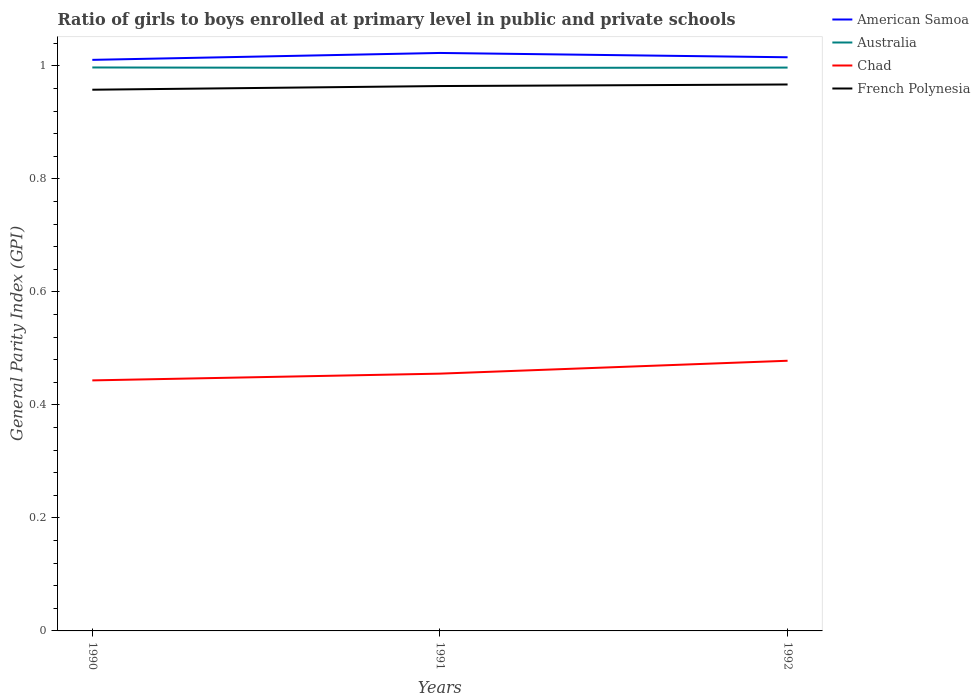How many different coloured lines are there?
Keep it short and to the point. 4. Is the number of lines equal to the number of legend labels?
Your answer should be very brief. Yes. Across all years, what is the maximum general parity index in Australia?
Your answer should be compact. 1. What is the total general parity index in Chad in the graph?
Make the answer very short. -0.03. What is the difference between the highest and the second highest general parity index in French Polynesia?
Give a very brief answer. 0.01. What is the difference between the highest and the lowest general parity index in Chad?
Provide a succinct answer. 1. Is the general parity index in Australia strictly greater than the general parity index in American Samoa over the years?
Your response must be concise. Yes. Does the graph contain any zero values?
Provide a short and direct response. No. Does the graph contain grids?
Give a very brief answer. No. Where does the legend appear in the graph?
Give a very brief answer. Top right. How many legend labels are there?
Keep it short and to the point. 4. What is the title of the graph?
Give a very brief answer. Ratio of girls to boys enrolled at primary level in public and private schools. What is the label or title of the X-axis?
Keep it short and to the point. Years. What is the label or title of the Y-axis?
Keep it short and to the point. General Parity Index (GPI). What is the General Parity Index (GPI) in American Samoa in 1990?
Give a very brief answer. 1.01. What is the General Parity Index (GPI) in Australia in 1990?
Ensure brevity in your answer.  1. What is the General Parity Index (GPI) in Chad in 1990?
Give a very brief answer. 0.44. What is the General Parity Index (GPI) in French Polynesia in 1990?
Your answer should be compact. 0.96. What is the General Parity Index (GPI) in American Samoa in 1991?
Provide a short and direct response. 1.02. What is the General Parity Index (GPI) of Australia in 1991?
Give a very brief answer. 1. What is the General Parity Index (GPI) of Chad in 1991?
Provide a succinct answer. 0.46. What is the General Parity Index (GPI) of French Polynesia in 1991?
Ensure brevity in your answer.  0.96. What is the General Parity Index (GPI) in American Samoa in 1992?
Your answer should be compact. 1.02. What is the General Parity Index (GPI) of Australia in 1992?
Give a very brief answer. 1. What is the General Parity Index (GPI) in Chad in 1992?
Make the answer very short. 0.48. What is the General Parity Index (GPI) of French Polynesia in 1992?
Make the answer very short. 0.97. Across all years, what is the maximum General Parity Index (GPI) in American Samoa?
Give a very brief answer. 1.02. Across all years, what is the maximum General Parity Index (GPI) of Australia?
Ensure brevity in your answer.  1. Across all years, what is the maximum General Parity Index (GPI) in Chad?
Your response must be concise. 0.48. Across all years, what is the maximum General Parity Index (GPI) of French Polynesia?
Make the answer very short. 0.97. Across all years, what is the minimum General Parity Index (GPI) in American Samoa?
Provide a succinct answer. 1.01. Across all years, what is the minimum General Parity Index (GPI) in Australia?
Give a very brief answer. 1. Across all years, what is the minimum General Parity Index (GPI) of Chad?
Make the answer very short. 0.44. Across all years, what is the minimum General Parity Index (GPI) in French Polynesia?
Provide a succinct answer. 0.96. What is the total General Parity Index (GPI) in American Samoa in the graph?
Your answer should be very brief. 3.05. What is the total General Parity Index (GPI) in Australia in the graph?
Make the answer very short. 2.99. What is the total General Parity Index (GPI) of Chad in the graph?
Your response must be concise. 1.38. What is the total General Parity Index (GPI) in French Polynesia in the graph?
Provide a short and direct response. 2.89. What is the difference between the General Parity Index (GPI) in American Samoa in 1990 and that in 1991?
Your answer should be very brief. -0.01. What is the difference between the General Parity Index (GPI) of Australia in 1990 and that in 1991?
Ensure brevity in your answer.  0. What is the difference between the General Parity Index (GPI) of Chad in 1990 and that in 1991?
Your response must be concise. -0.01. What is the difference between the General Parity Index (GPI) in French Polynesia in 1990 and that in 1991?
Offer a very short reply. -0.01. What is the difference between the General Parity Index (GPI) in American Samoa in 1990 and that in 1992?
Ensure brevity in your answer.  -0. What is the difference between the General Parity Index (GPI) in Australia in 1990 and that in 1992?
Your response must be concise. 0. What is the difference between the General Parity Index (GPI) in Chad in 1990 and that in 1992?
Give a very brief answer. -0.03. What is the difference between the General Parity Index (GPI) of French Polynesia in 1990 and that in 1992?
Provide a succinct answer. -0.01. What is the difference between the General Parity Index (GPI) in American Samoa in 1991 and that in 1992?
Offer a terse response. 0.01. What is the difference between the General Parity Index (GPI) of Australia in 1991 and that in 1992?
Make the answer very short. -0. What is the difference between the General Parity Index (GPI) in Chad in 1991 and that in 1992?
Give a very brief answer. -0.02. What is the difference between the General Parity Index (GPI) in French Polynesia in 1991 and that in 1992?
Give a very brief answer. -0. What is the difference between the General Parity Index (GPI) in American Samoa in 1990 and the General Parity Index (GPI) in Australia in 1991?
Offer a very short reply. 0.01. What is the difference between the General Parity Index (GPI) of American Samoa in 1990 and the General Parity Index (GPI) of Chad in 1991?
Your response must be concise. 0.56. What is the difference between the General Parity Index (GPI) of American Samoa in 1990 and the General Parity Index (GPI) of French Polynesia in 1991?
Provide a succinct answer. 0.05. What is the difference between the General Parity Index (GPI) of Australia in 1990 and the General Parity Index (GPI) of Chad in 1991?
Give a very brief answer. 0.54. What is the difference between the General Parity Index (GPI) of Australia in 1990 and the General Parity Index (GPI) of French Polynesia in 1991?
Your response must be concise. 0.03. What is the difference between the General Parity Index (GPI) of Chad in 1990 and the General Parity Index (GPI) of French Polynesia in 1991?
Offer a terse response. -0.52. What is the difference between the General Parity Index (GPI) of American Samoa in 1990 and the General Parity Index (GPI) of Australia in 1992?
Your answer should be compact. 0.01. What is the difference between the General Parity Index (GPI) of American Samoa in 1990 and the General Parity Index (GPI) of Chad in 1992?
Ensure brevity in your answer.  0.53. What is the difference between the General Parity Index (GPI) in American Samoa in 1990 and the General Parity Index (GPI) in French Polynesia in 1992?
Your response must be concise. 0.04. What is the difference between the General Parity Index (GPI) of Australia in 1990 and the General Parity Index (GPI) of Chad in 1992?
Offer a very short reply. 0.52. What is the difference between the General Parity Index (GPI) of Australia in 1990 and the General Parity Index (GPI) of French Polynesia in 1992?
Your response must be concise. 0.03. What is the difference between the General Parity Index (GPI) of Chad in 1990 and the General Parity Index (GPI) of French Polynesia in 1992?
Provide a succinct answer. -0.52. What is the difference between the General Parity Index (GPI) in American Samoa in 1991 and the General Parity Index (GPI) in Australia in 1992?
Provide a short and direct response. 0.03. What is the difference between the General Parity Index (GPI) of American Samoa in 1991 and the General Parity Index (GPI) of Chad in 1992?
Your answer should be compact. 0.54. What is the difference between the General Parity Index (GPI) in American Samoa in 1991 and the General Parity Index (GPI) in French Polynesia in 1992?
Offer a terse response. 0.06. What is the difference between the General Parity Index (GPI) in Australia in 1991 and the General Parity Index (GPI) in Chad in 1992?
Provide a succinct answer. 0.52. What is the difference between the General Parity Index (GPI) in Australia in 1991 and the General Parity Index (GPI) in French Polynesia in 1992?
Your answer should be very brief. 0.03. What is the difference between the General Parity Index (GPI) of Chad in 1991 and the General Parity Index (GPI) of French Polynesia in 1992?
Offer a very short reply. -0.51. What is the average General Parity Index (GPI) in American Samoa per year?
Keep it short and to the point. 1.02. What is the average General Parity Index (GPI) of Chad per year?
Keep it short and to the point. 0.46. In the year 1990, what is the difference between the General Parity Index (GPI) in American Samoa and General Parity Index (GPI) in Australia?
Make the answer very short. 0.01. In the year 1990, what is the difference between the General Parity Index (GPI) in American Samoa and General Parity Index (GPI) in Chad?
Your answer should be very brief. 0.57. In the year 1990, what is the difference between the General Parity Index (GPI) of American Samoa and General Parity Index (GPI) of French Polynesia?
Your answer should be very brief. 0.05. In the year 1990, what is the difference between the General Parity Index (GPI) of Australia and General Parity Index (GPI) of Chad?
Provide a short and direct response. 0.55. In the year 1990, what is the difference between the General Parity Index (GPI) in Australia and General Parity Index (GPI) in French Polynesia?
Your answer should be compact. 0.04. In the year 1990, what is the difference between the General Parity Index (GPI) of Chad and General Parity Index (GPI) of French Polynesia?
Your response must be concise. -0.51. In the year 1991, what is the difference between the General Parity Index (GPI) of American Samoa and General Parity Index (GPI) of Australia?
Ensure brevity in your answer.  0.03. In the year 1991, what is the difference between the General Parity Index (GPI) in American Samoa and General Parity Index (GPI) in Chad?
Ensure brevity in your answer.  0.57. In the year 1991, what is the difference between the General Parity Index (GPI) of American Samoa and General Parity Index (GPI) of French Polynesia?
Your answer should be compact. 0.06. In the year 1991, what is the difference between the General Parity Index (GPI) in Australia and General Parity Index (GPI) in Chad?
Ensure brevity in your answer.  0.54. In the year 1991, what is the difference between the General Parity Index (GPI) of Australia and General Parity Index (GPI) of French Polynesia?
Give a very brief answer. 0.03. In the year 1991, what is the difference between the General Parity Index (GPI) in Chad and General Parity Index (GPI) in French Polynesia?
Your answer should be very brief. -0.51. In the year 1992, what is the difference between the General Parity Index (GPI) in American Samoa and General Parity Index (GPI) in Australia?
Your answer should be very brief. 0.02. In the year 1992, what is the difference between the General Parity Index (GPI) of American Samoa and General Parity Index (GPI) of Chad?
Your response must be concise. 0.54. In the year 1992, what is the difference between the General Parity Index (GPI) of American Samoa and General Parity Index (GPI) of French Polynesia?
Keep it short and to the point. 0.05. In the year 1992, what is the difference between the General Parity Index (GPI) in Australia and General Parity Index (GPI) in Chad?
Keep it short and to the point. 0.52. In the year 1992, what is the difference between the General Parity Index (GPI) in Australia and General Parity Index (GPI) in French Polynesia?
Make the answer very short. 0.03. In the year 1992, what is the difference between the General Parity Index (GPI) in Chad and General Parity Index (GPI) in French Polynesia?
Your answer should be very brief. -0.49. What is the ratio of the General Parity Index (GPI) of Australia in 1990 to that in 1991?
Provide a succinct answer. 1. What is the ratio of the General Parity Index (GPI) in Chad in 1990 to that in 1991?
Provide a succinct answer. 0.97. What is the ratio of the General Parity Index (GPI) of Chad in 1990 to that in 1992?
Keep it short and to the point. 0.93. What is the ratio of the General Parity Index (GPI) of French Polynesia in 1990 to that in 1992?
Make the answer very short. 0.99. What is the ratio of the General Parity Index (GPI) of American Samoa in 1991 to that in 1992?
Your response must be concise. 1.01. What is the ratio of the General Parity Index (GPI) in Australia in 1991 to that in 1992?
Your answer should be compact. 1. What is the ratio of the General Parity Index (GPI) in Chad in 1991 to that in 1992?
Provide a short and direct response. 0.95. What is the difference between the highest and the second highest General Parity Index (GPI) of American Samoa?
Make the answer very short. 0.01. What is the difference between the highest and the second highest General Parity Index (GPI) in Australia?
Your answer should be very brief. 0. What is the difference between the highest and the second highest General Parity Index (GPI) of Chad?
Offer a terse response. 0.02. What is the difference between the highest and the second highest General Parity Index (GPI) in French Polynesia?
Give a very brief answer. 0. What is the difference between the highest and the lowest General Parity Index (GPI) in American Samoa?
Your answer should be compact. 0.01. What is the difference between the highest and the lowest General Parity Index (GPI) of Australia?
Your response must be concise. 0. What is the difference between the highest and the lowest General Parity Index (GPI) in Chad?
Provide a short and direct response. 0.03. What is the difference between the highest and the lowest General Parity Index (GPI) of French Polynesia?
Make the answer very short. 0.01. 